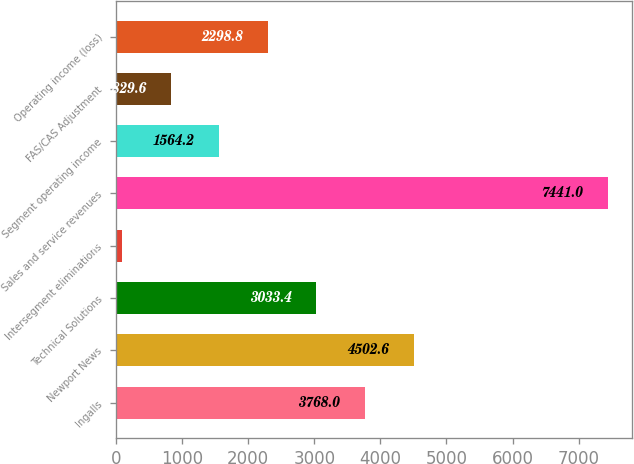Convert chart to OTSL. <chart><loc_0><loc_0><loc_500><loc_500><bar_chart><fcel>Ingalls<fcel>Newport News<fcel>Technical Solutions<fcel>Intersegment eliminations<fcel>Sales and service revenues<fcel>Segment operating income<fcel>FAS/CAS Adjustment<fcel>Operating income (loss)<nl><fcel>3768<fcel>4502.6<fcel>3033.4<fcel>95<fcel>7441<fcel>1564.2<fcel>829.6<fcel>2298.8<nl></chart> 